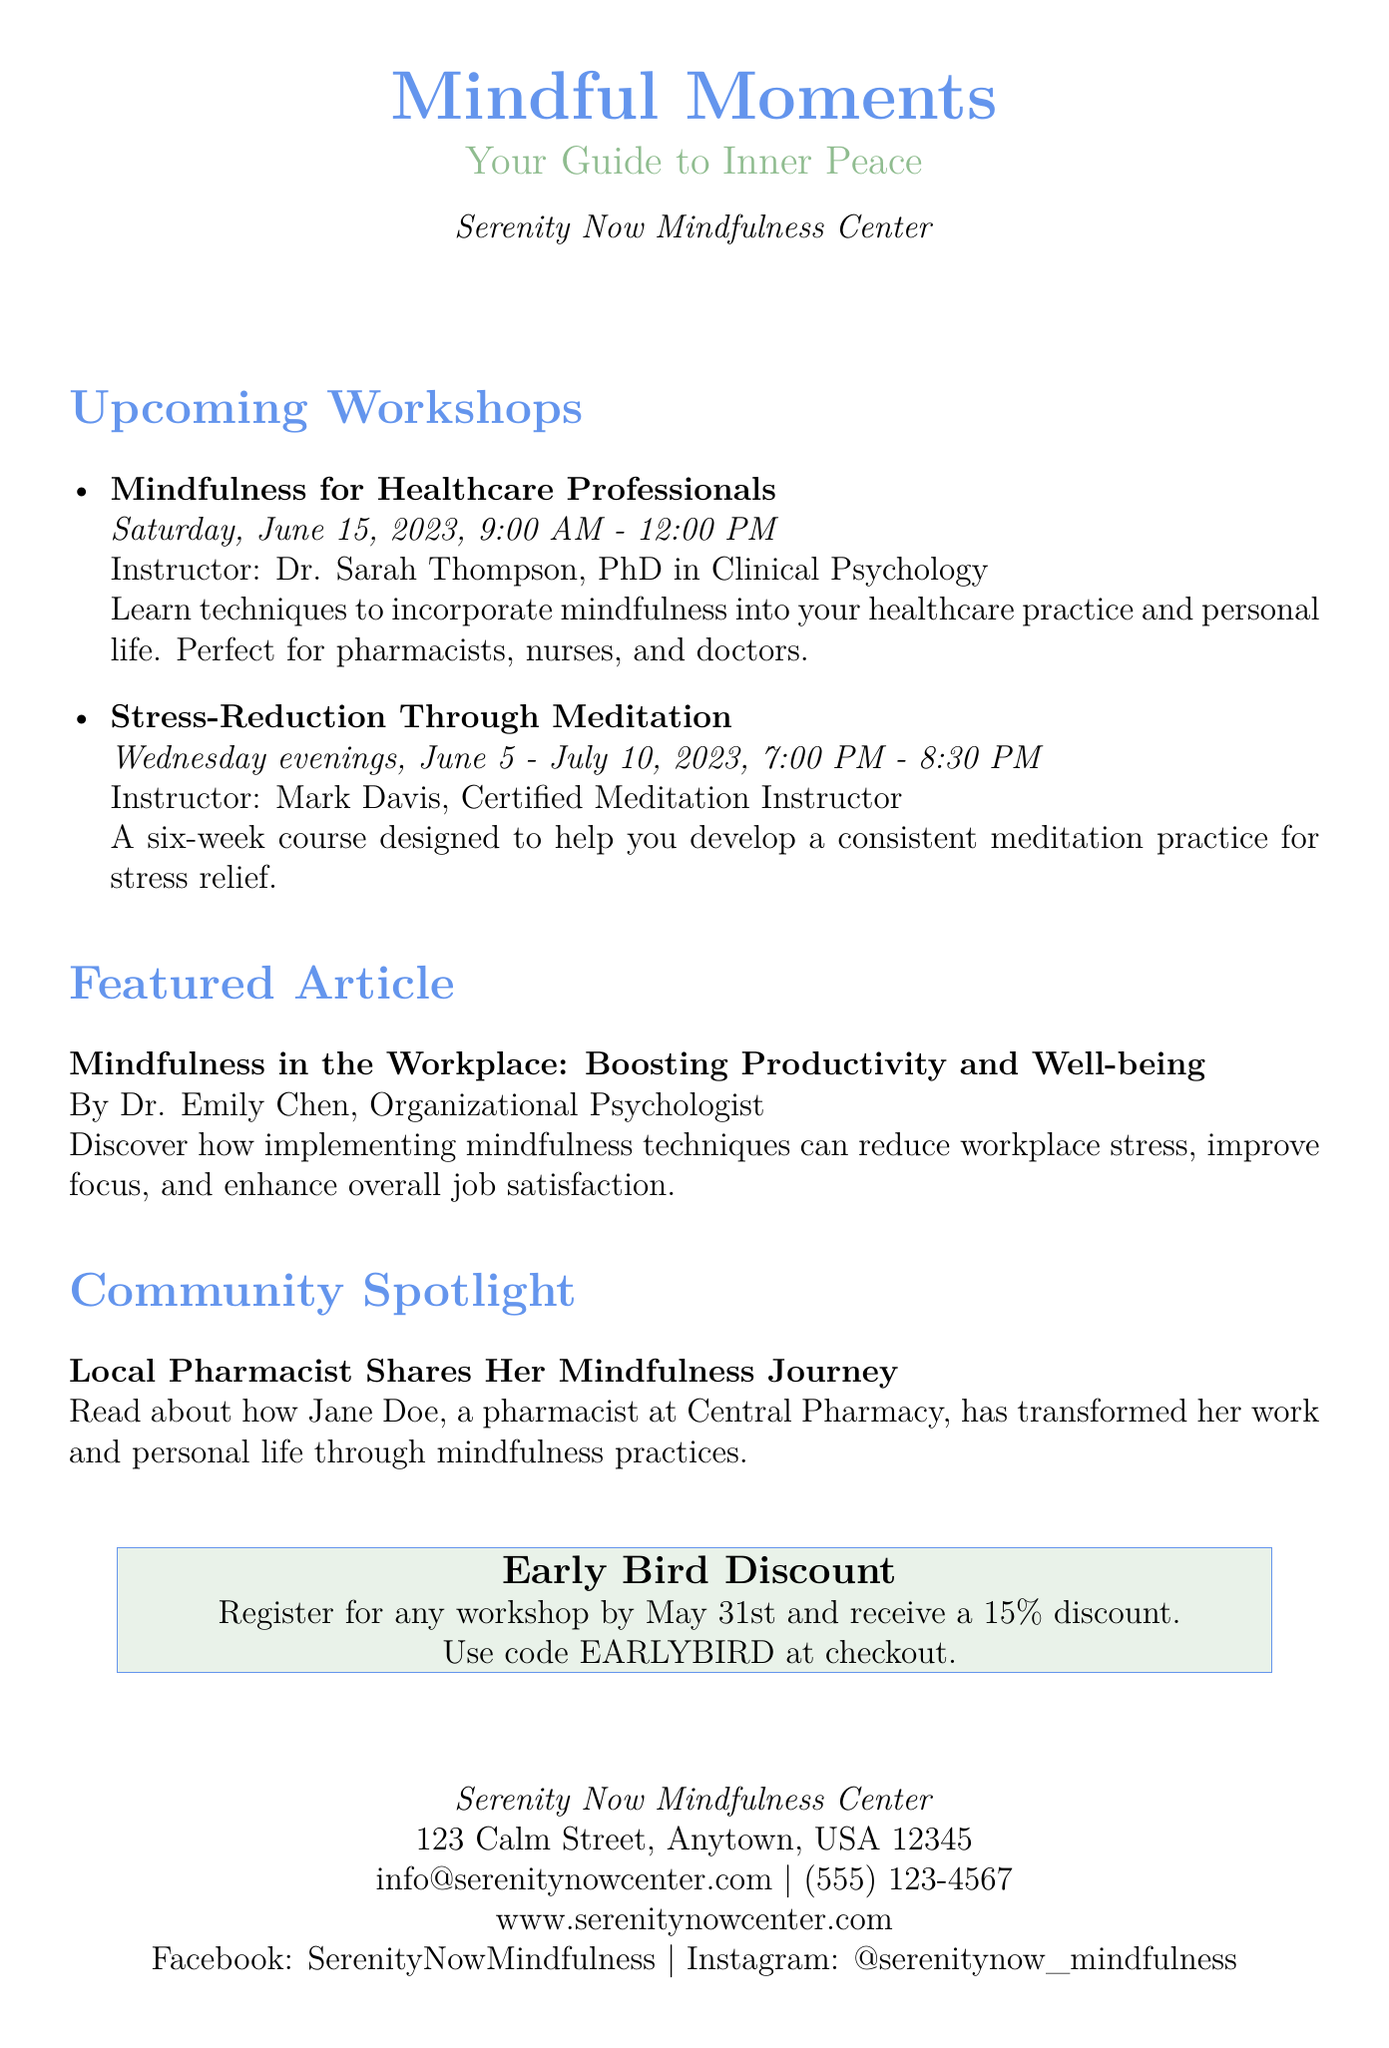What is the name of the mindfulness center? The name of the mindfulness center is mentioned at the beginning of the document.
Answer: Serenity Now Mindfulness Center What is the date of the "Mindfulness for Healthcare Professionals" workshop? The document specifies the date for this workshop in the list of upcoming workshops.
Answer: Saturday, June 15, 2023 Who is the instructor for the "Stress-Reduction Through Meditation" workshop? The instructor's name is included in the details of the workshop within the document.
Answer: Mark Davis What discount is offered for early registration? The document outlines a special offer regarding early registration for workshops.
Answer: 15% discount What is the title of the featured article? The document provides the title of the featured article in the section with the same name.
Answer: Mindfulness in the Workplace: Boosting Productivity and Well-being Which community member's mindfulness journey is spotlighted? The document mentions a specific member in the community spotlight section.
Answer: Jane Doe How long is the "Stress-Reduction Through Meditation" course? The duration of the course is detailed in the workshop information.
Answer: Six weeks What is the code for the early bird discount? The document specifies a code to use for the discount in the special offer section.
Answer: EARLYBIRD 